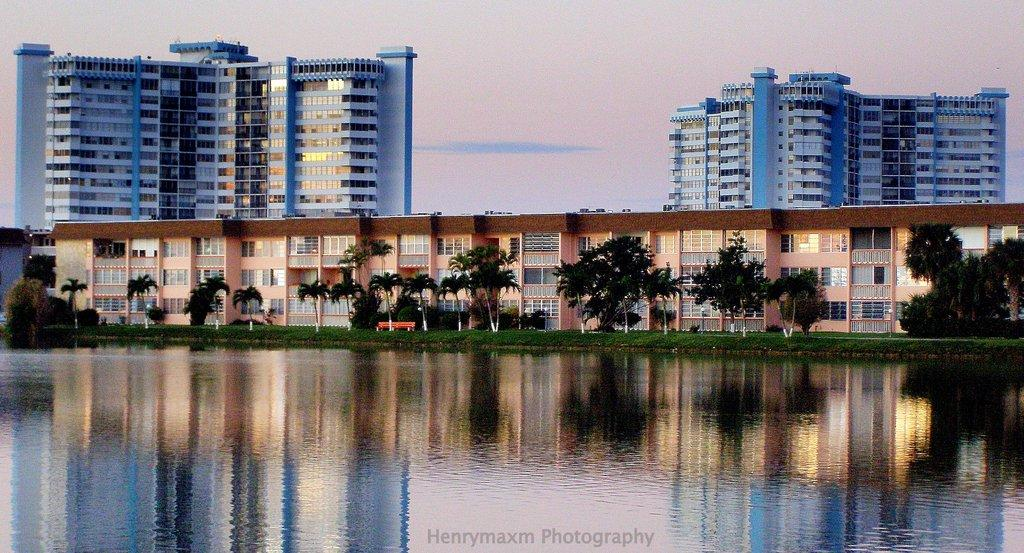What is located in the center of the image? There are buildings and trees in the center of the image. What can be seen at the bottom of the image? There is water visible at the bottom of the image. What is written in the image? There is text written in the image. What is visible at the top of the image? The sky is visible at the top of the image. Can you see a quill being used to write the text in the image? There is no quill visible in the image, and the method of writing the text is not specified. Is there a bomb present in the image? There is no bomb present in the image. 